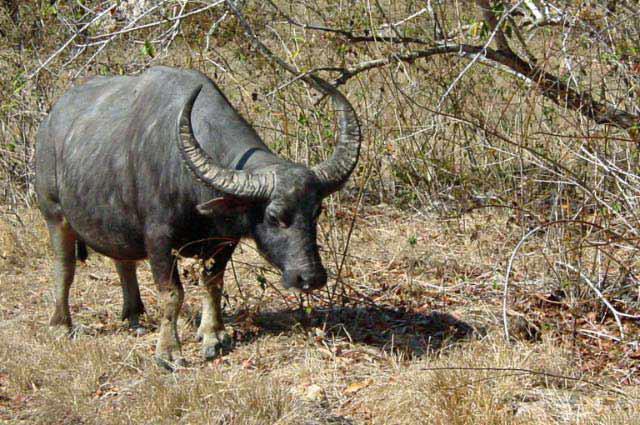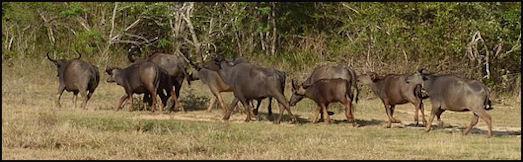The first image is the image on the left, the second image is the image on the right. Assess this claim about the two images: "There are exactly two water buffalo in the left image.". Correct or not? Answer yes or no. No. The first image is the image on the left, the second image is the image on the right. Evaluate the accuracy of this statement regarding the images: "The left image shows one adult in a hat holding a stick behind a team of two hitched oxen walking in a wet area.". Is it true? Answer yes or no. No. 